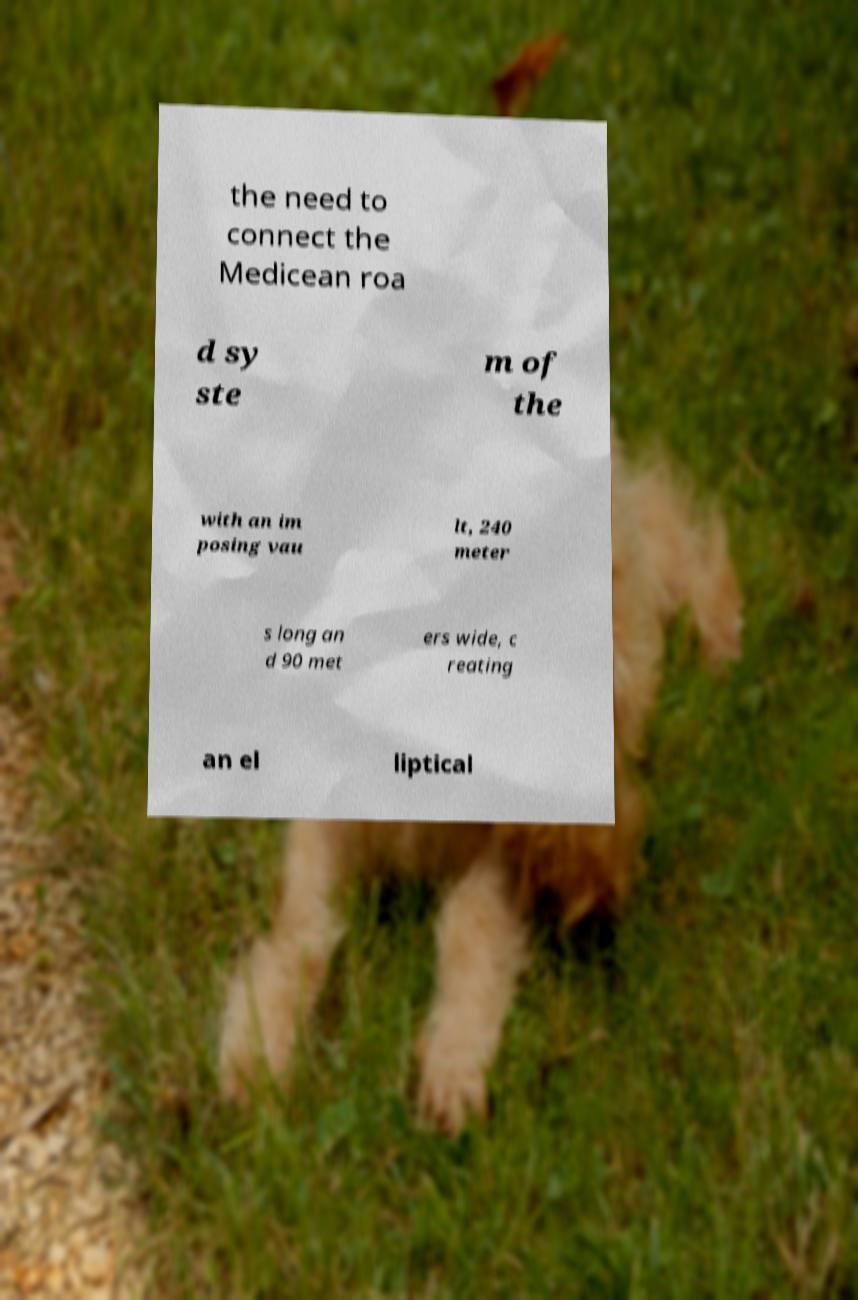For documentation purposes, I need the text within this image transcribed. Could you provide that? the need to connect the Medicean roa d sy ste m of the with an im posing vau lt, 240 meter s long an d 90 met ers wide, c reating an el liptical 